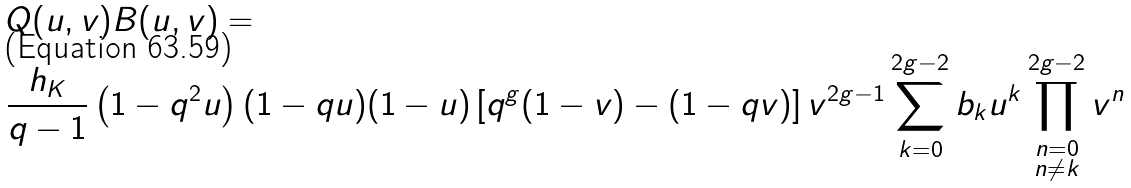<formula> <loc_0><loc_0><loc_500><loc_500>& Q ( u , v ) B ( u , v ) = \\ & \frac { h _ { K } } { q - 1 } \left ( 1 - q ^ { 2 } u \right ) ( 1 - q u ) ( 1 - u ) \left [ q ^ { g } ( 1 - v ) - ( 1 - q v ) \right ] v ^ { 2 g - 1 } \sum _ { k = 0 } ^ { 2 g - 2 } b _ { k } u ^ { k } \prod _ { \substack { n = 0 \\ n \neq k } } ^ { 2 g - 2 } v ^ { n }</formula> 